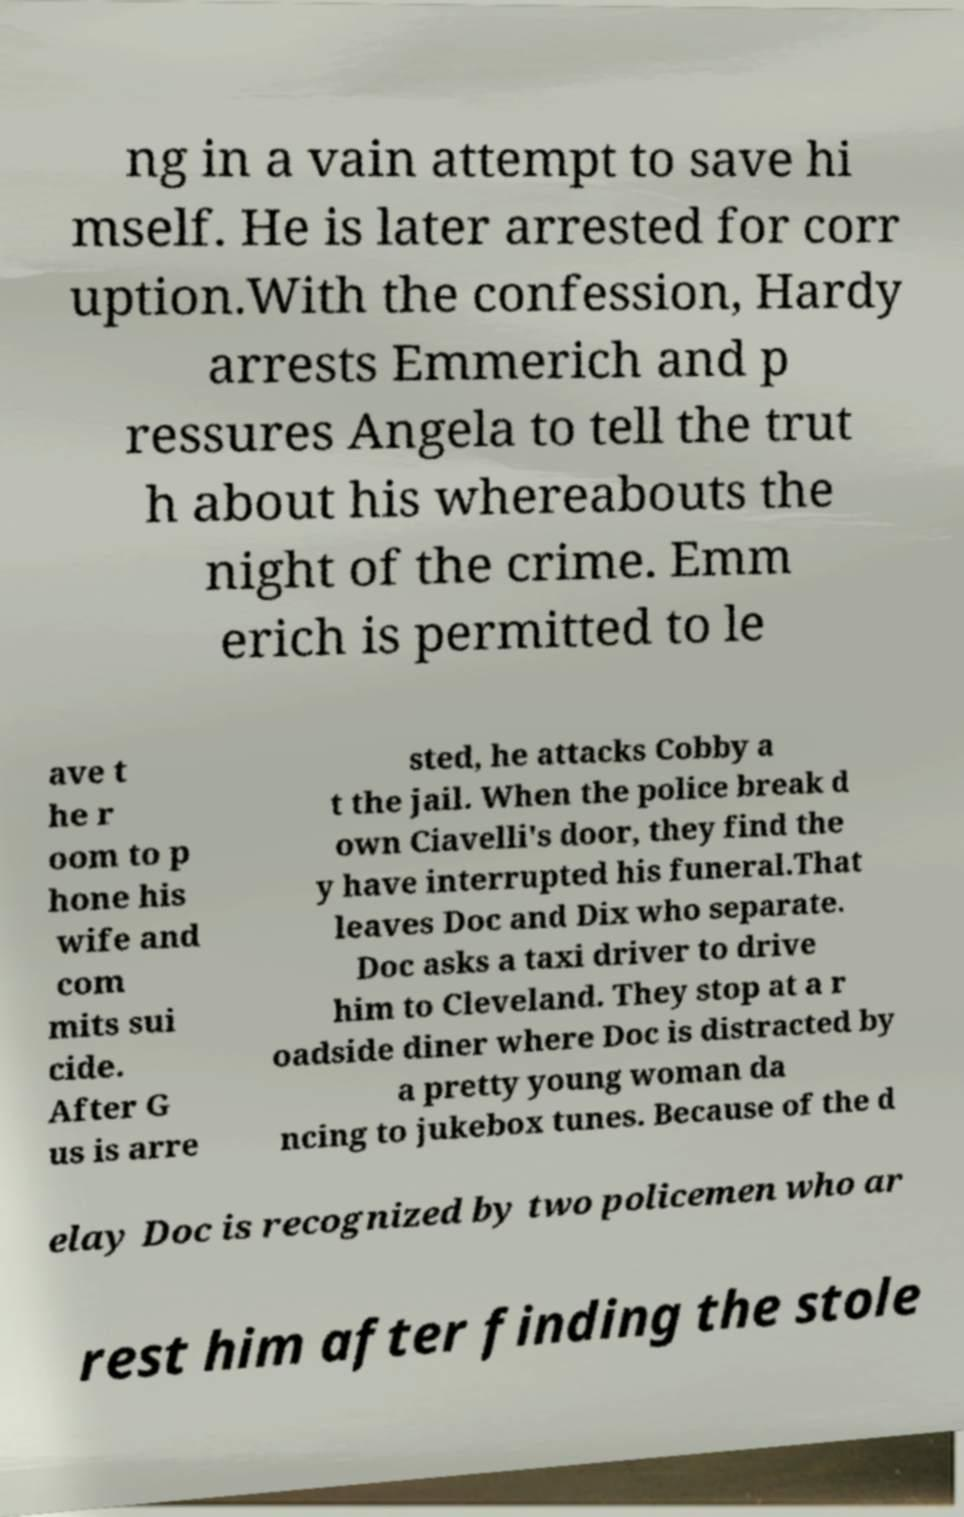Please identify and transcribe the text found in this image. ng in a vain attempt to save hi mself. He is later arrested for corr uption.With the confession, Hardy arrests Emmerich and p ressures Angela to tell the trut h about his whereabouts the night of the crime. Emm erich is permitted to le ave t he r oom to p hone his wife and com mits sui cide. After G us is arre sted, he attacks Cobby a t the jail. When the police break d own Ciavelli's door, they find the y have interrupted his funeral.That leaves Doc and Dix who separate. Doc asks a taxi driver to drive him to Cleveland. They stop at a r oadside diner where Doc is distracted by a pretty young woman da ncing to jukebox tunes. Because of the d elay Doc is recognized by two policemen who ar rest him after finding the stole 